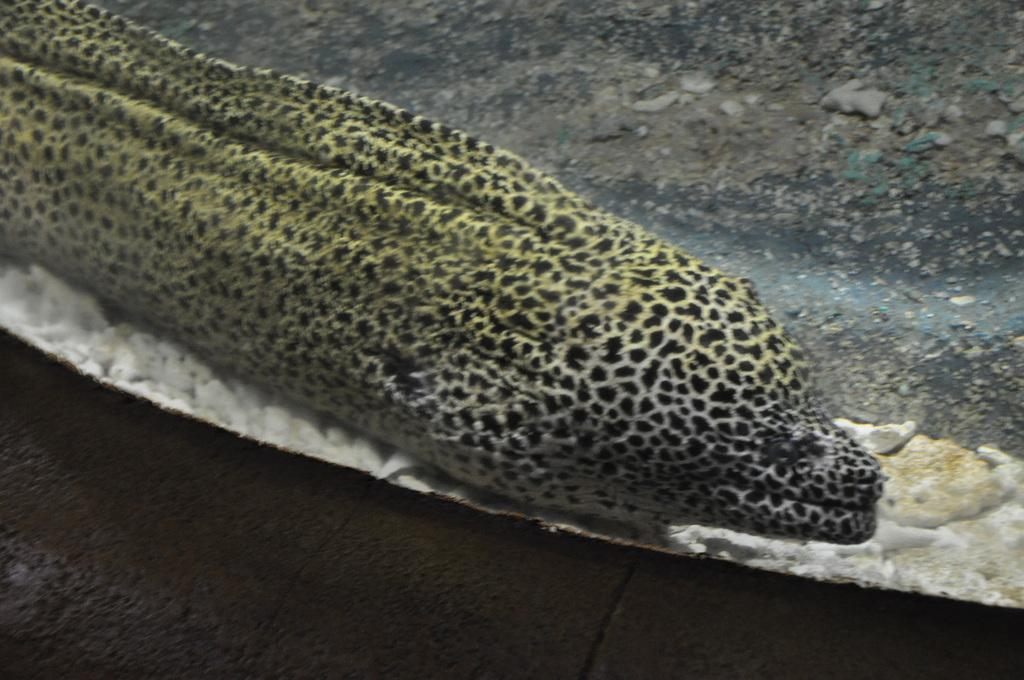What is the main subject of the image? The main subject of the image is a fish swimming in the water. Can you describe the appearance of the fish? The fish has green and black color. What can be seen in the background of the image? There are stones and a ground visible in the background of the image. What type of wren can be seen perched on the flag in the image? There is no wren or flag present in the image; it features a fish swimming in the water. 